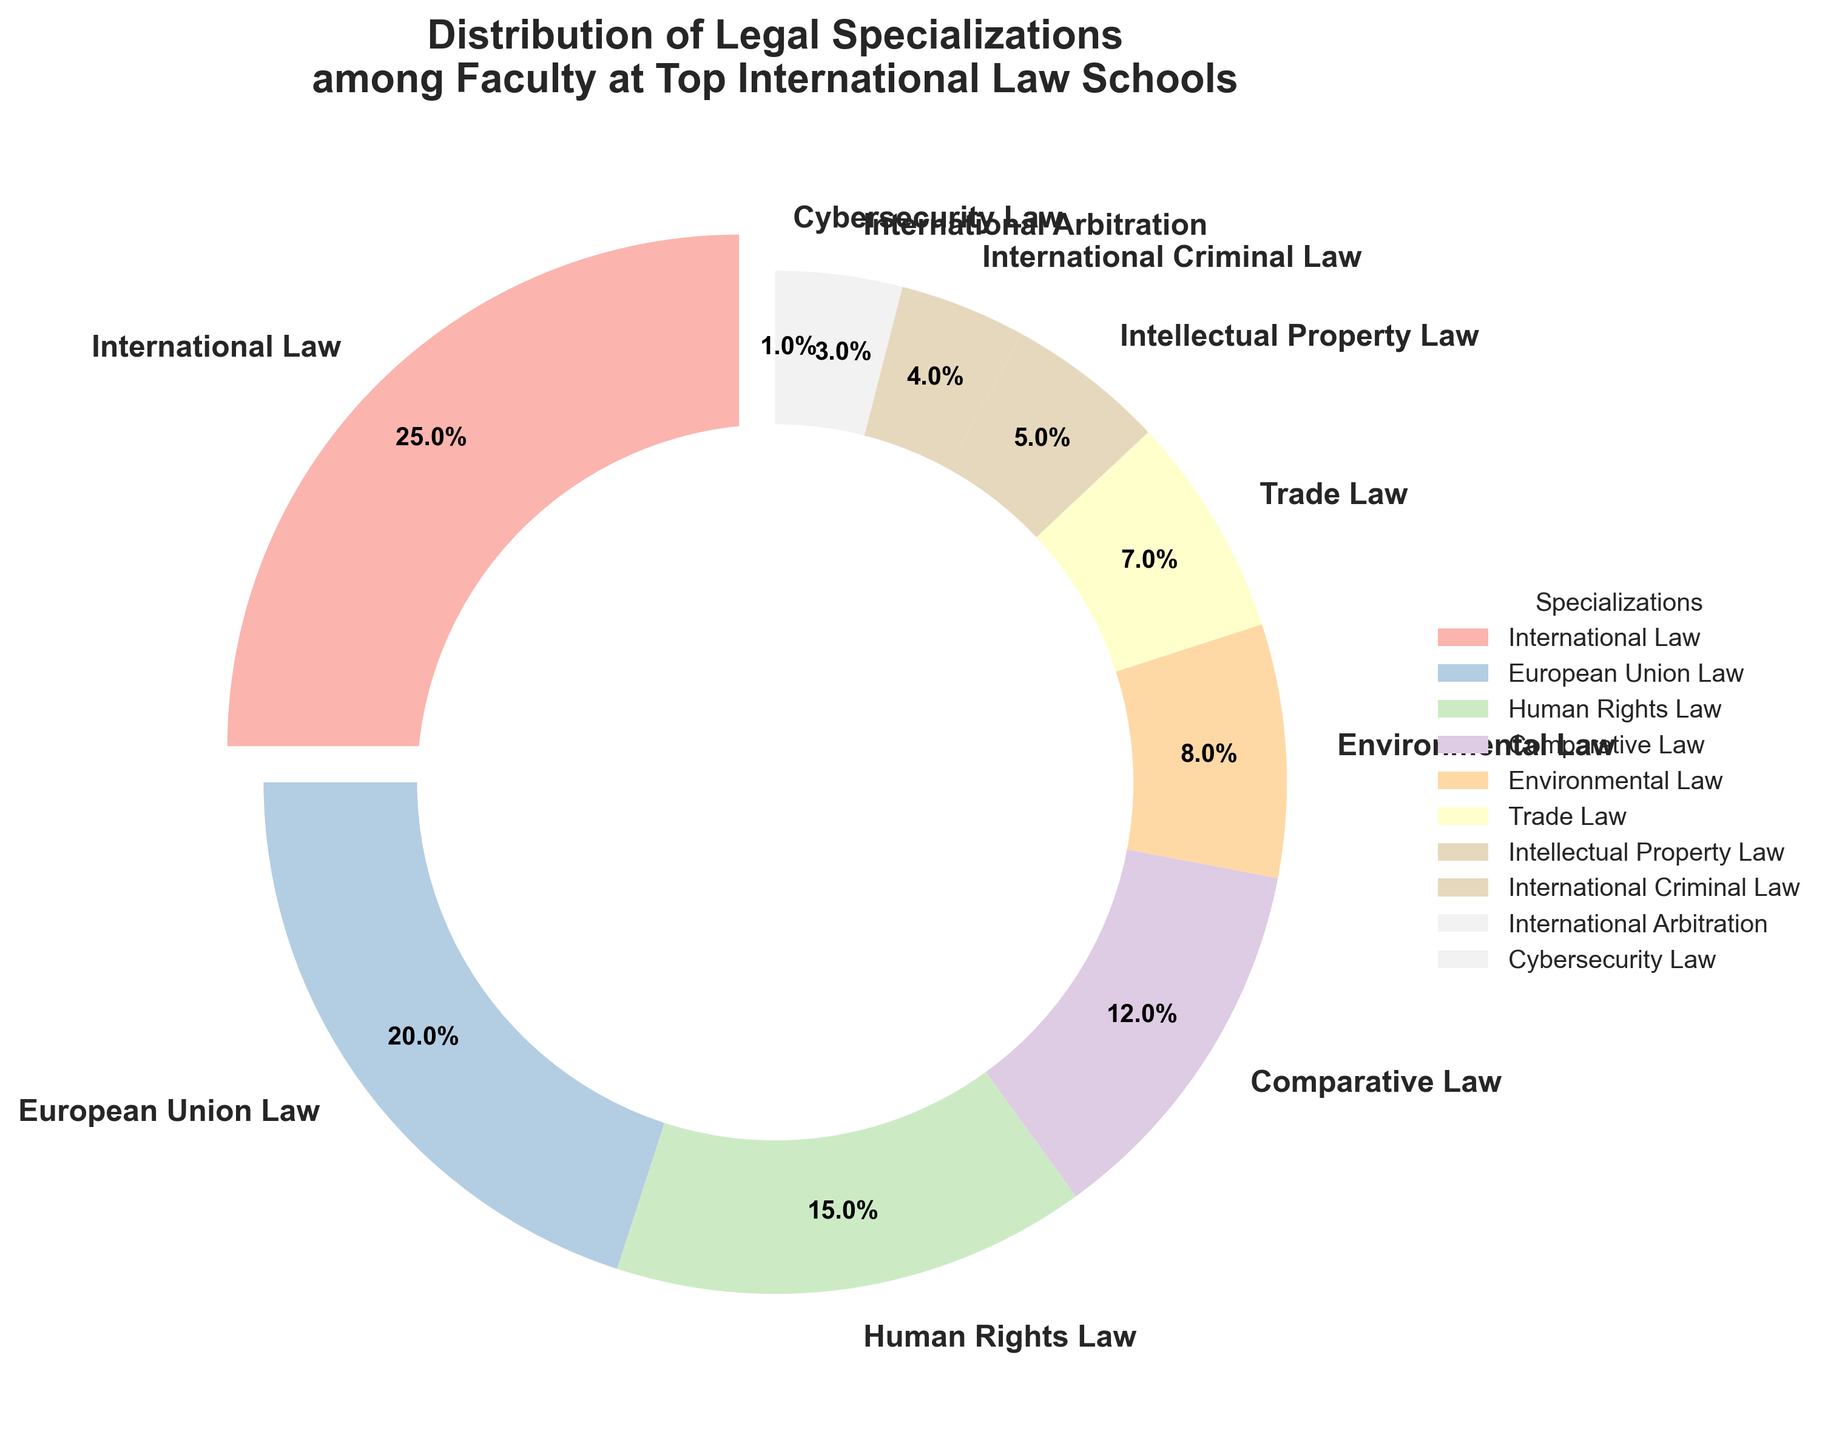What is the most common legal specialization among the faculty? The most common specialization can be determined by identifying the segment of the pie chart with the largest percentage. The segment labeled "International Law" is the largest, with 25%.
Answer: International Law Which specializations have a higher percentage than Comparative Law? Comparative Law is at 12%. The pie chart shows that International Law (25%), European Union Law (20%), and Human Rights Law (15%) each have a higher percentage.
Answer: International Law, European Union Law, Human Rights Law What is the total percentage for the three least represented specializations? The three least represented specializations are Cybersecurity Law (1%), International Arbitration (3%), and International Criminal Law (4%). Adding these percentages: 1% + 3% + 4% = 8%.
Answer: 8% How much more common is International Law compared to Intellectual Property Law? International Law is 25%, and Intellectual Property Law is 5%. The difference is 25% - 5% = 20%.
Answer: 20% What is the combined percentage of Human Rights Law and Environmental Law? Human Rights Law is 15%, and Environmental Law is 8%. Adding them together: 15% + 8% = 23%.
Answer: 23% Which specialization has the smallest representation, and what is its percentage? The smallest segment of the pie chart represents Cybersecurity Law, which has a percentage of 1%.
Answer: Cybersecurity Law, 1% If the Environmental Law percentage increased by 3% and the Trade Law percentage decreased by 3%, how would their new percentages compare? Currently, Environmental Law is 8% and Trade Law is 7%. With the changes, Environmental Law would be 8% + 3% = 11%, and Trade Law would be 7% - 3% = 4%. Environmental Law would be greater.
Answer: Environmental Law: 11%, Trade Law: 4% How many specializations have a percentage of 10% or more? The specializations with 10% or more are International Law (25%), European Union Law (20%), Human Rights Law (15%), and Comparative Law (12%). This totals to 4 specializations.
Answer: 4 